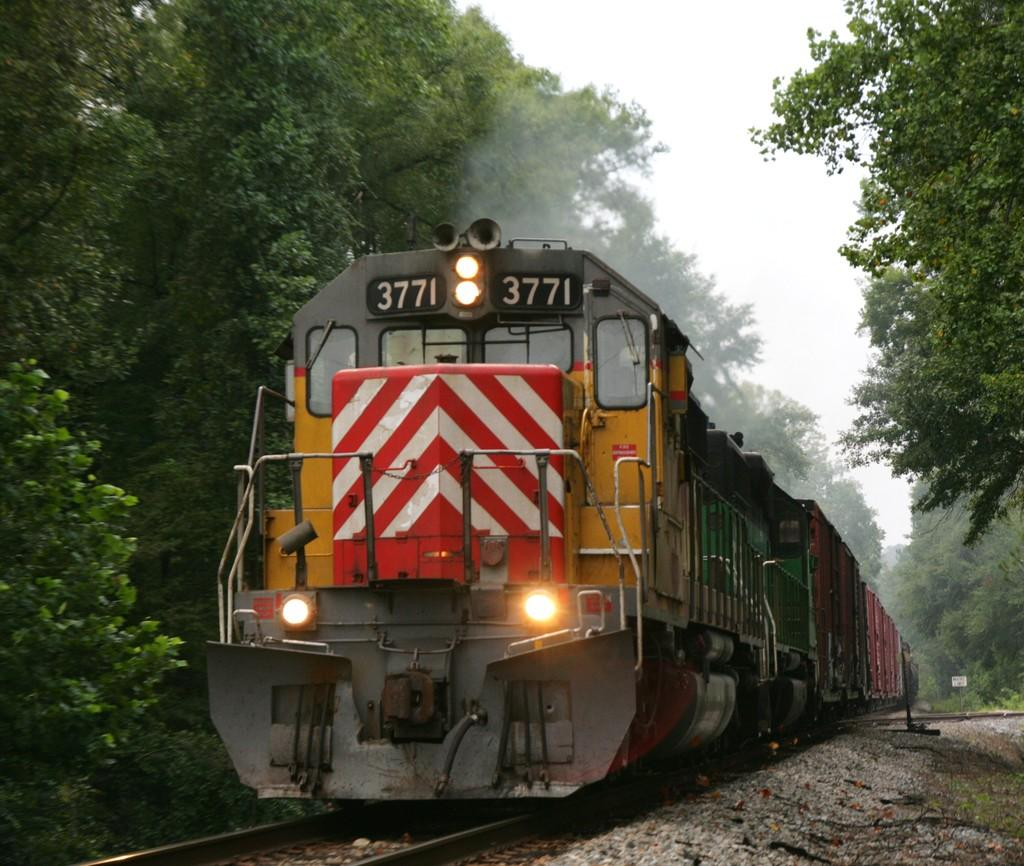What is the main subject of the image? The main subject of the image is a train. Where is the train located in the image? The train is on a railway track. What can be seen in the surroundings of the train? There are plenty of trees around the train. What day of the week is it in the image? The day of the week is not mentioned or visible in the image. What part of the train is visible in the image? The entire train is visible in the image, so it is not possible to determine a specific part. 